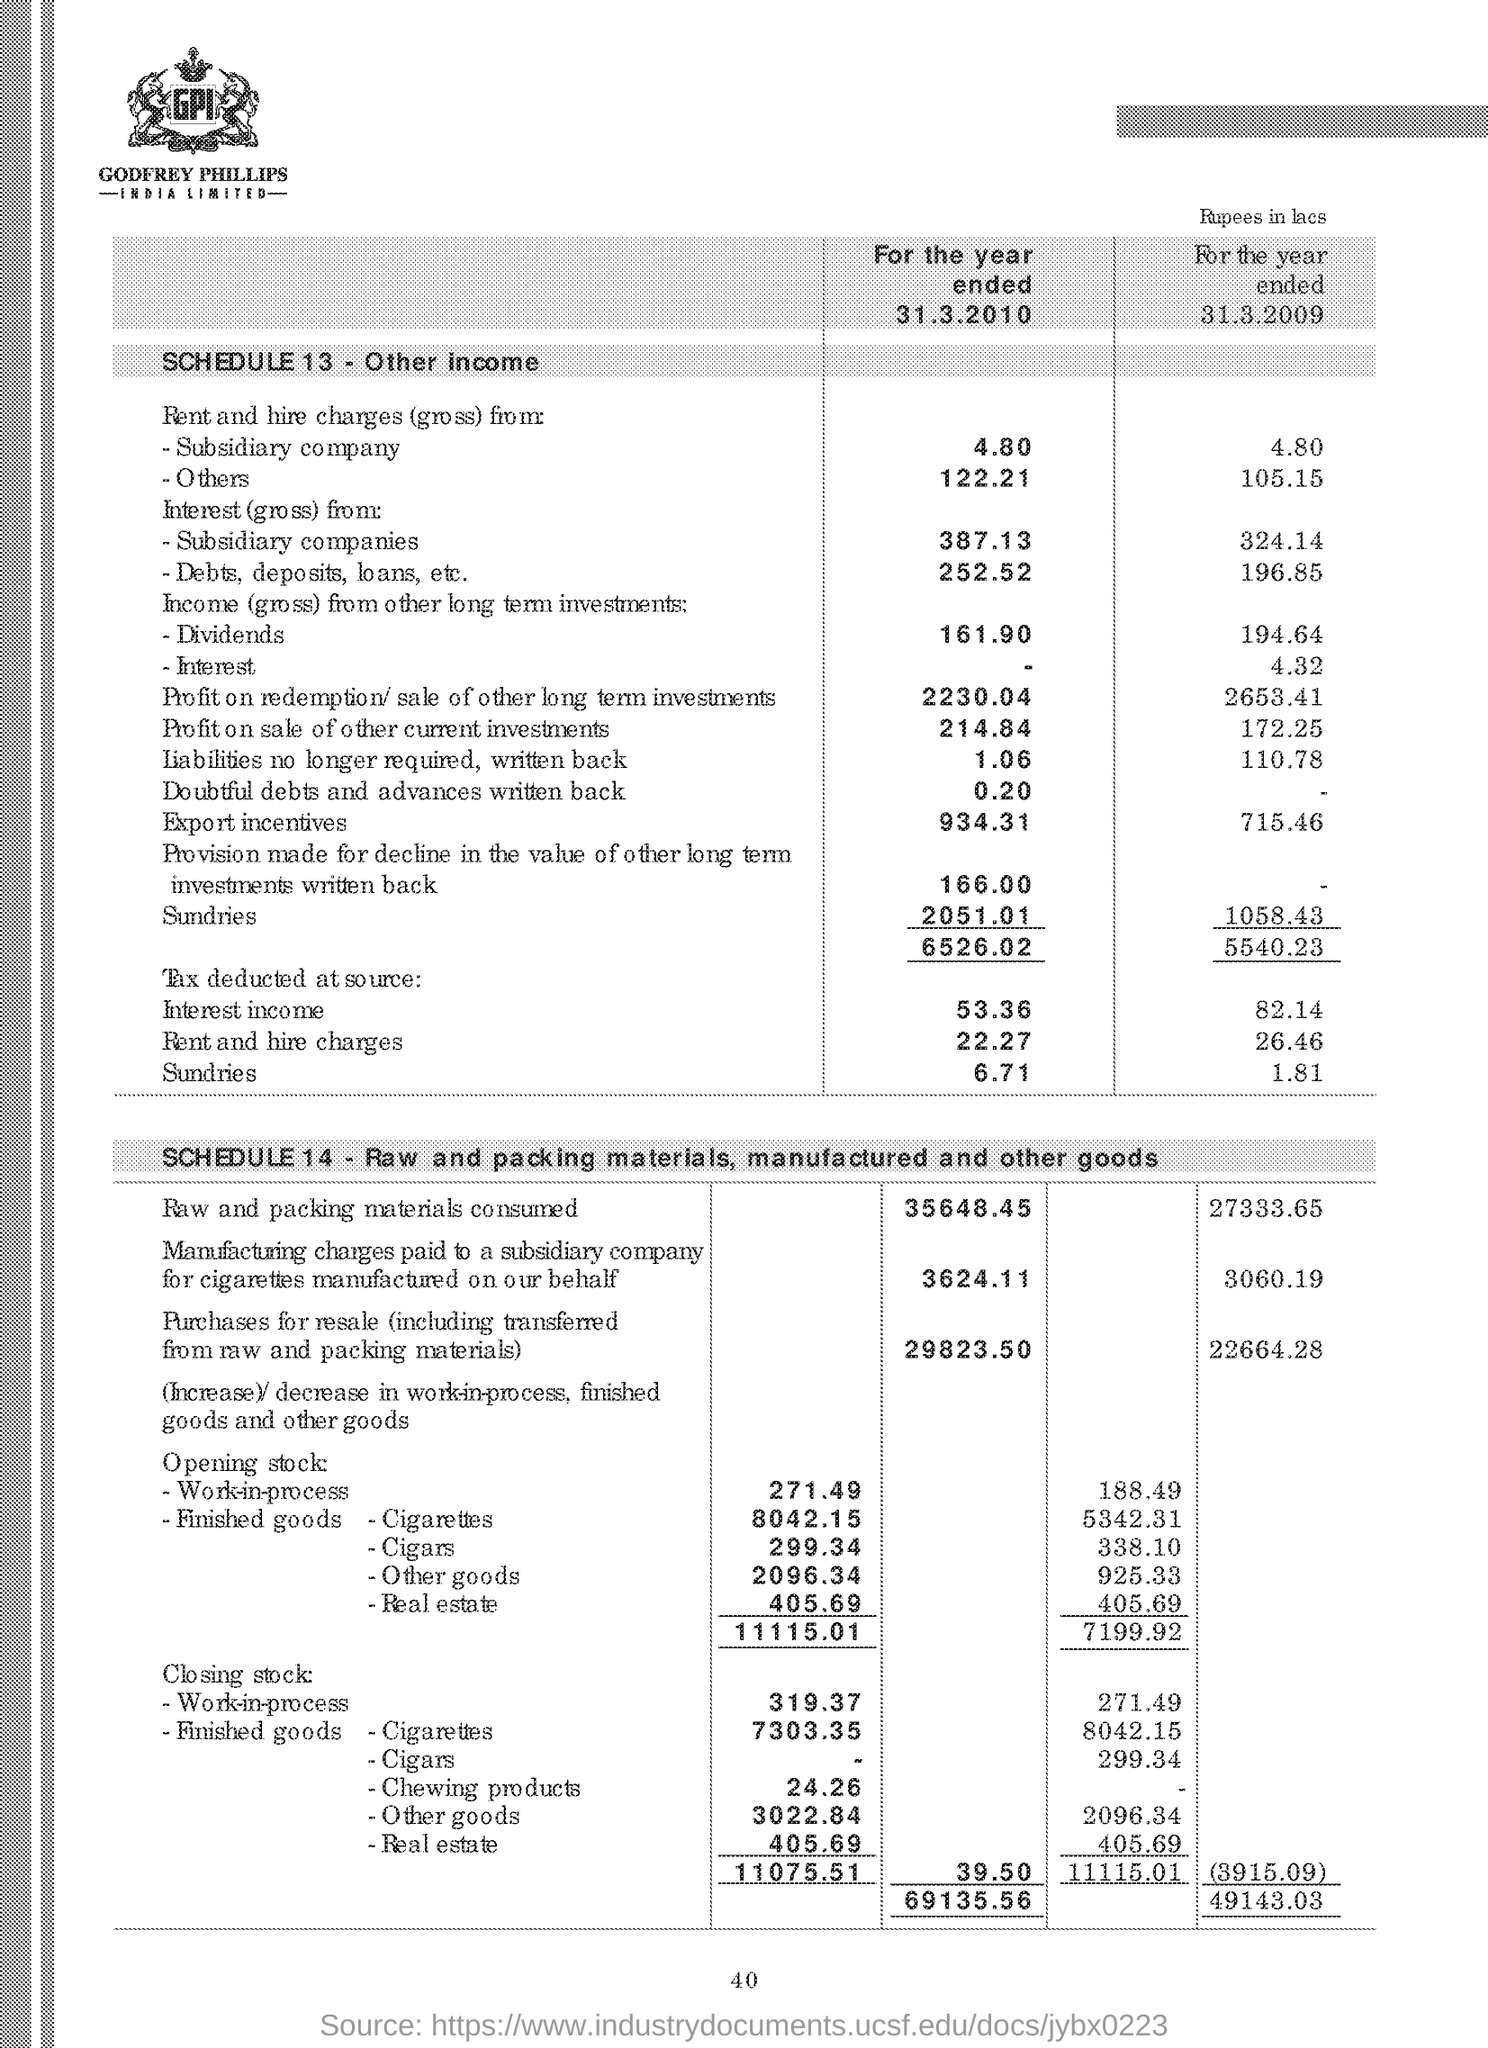List a handful of essential elements in this visual. Schedule 13 refers to "OTHER INCOME". In the year 2010, the amount of raw and packing materials consumed was 35,648.45. 